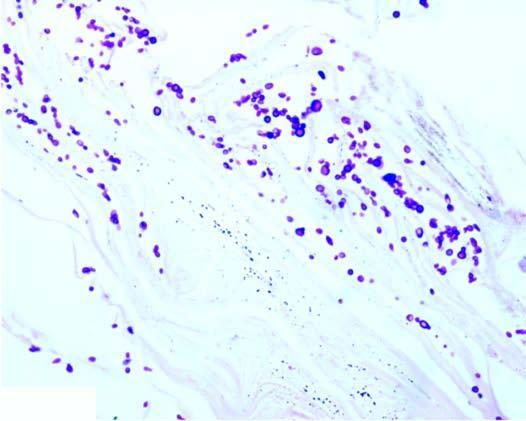does the stratum corneum around the hair follicle show presence of numerous arthrospores and hyphae?
Answer the question using a single word or phrase. Yes 